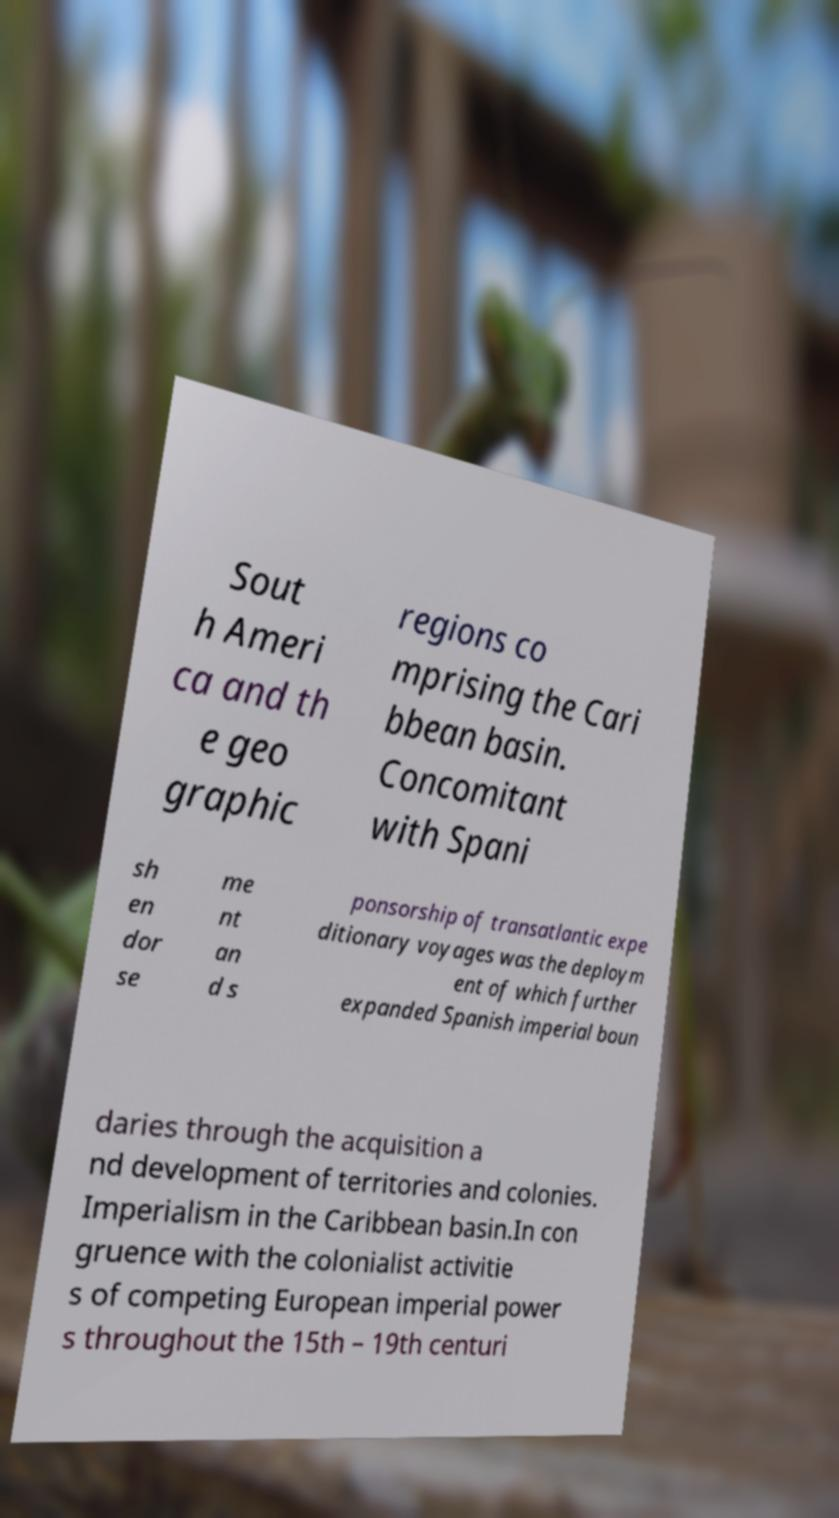I need the written content from this picture converted into text. Can you do that? Sout h Ameri ca and th e geo graphic regions co mprising the Cari bbean basin. Concomitant with Spani sh en dor se me nt an d s ponsorship of transatlantic expe ditionary voyages was the deploym ent of which further expanded Spanish imperial boun daries through the acquisition a nd development of territories and colonies. Imperialism in the Caribbean basin.In con gruence with the colonialist activitie s of competing European imperial power s throughout the 15th – 19th centuri 